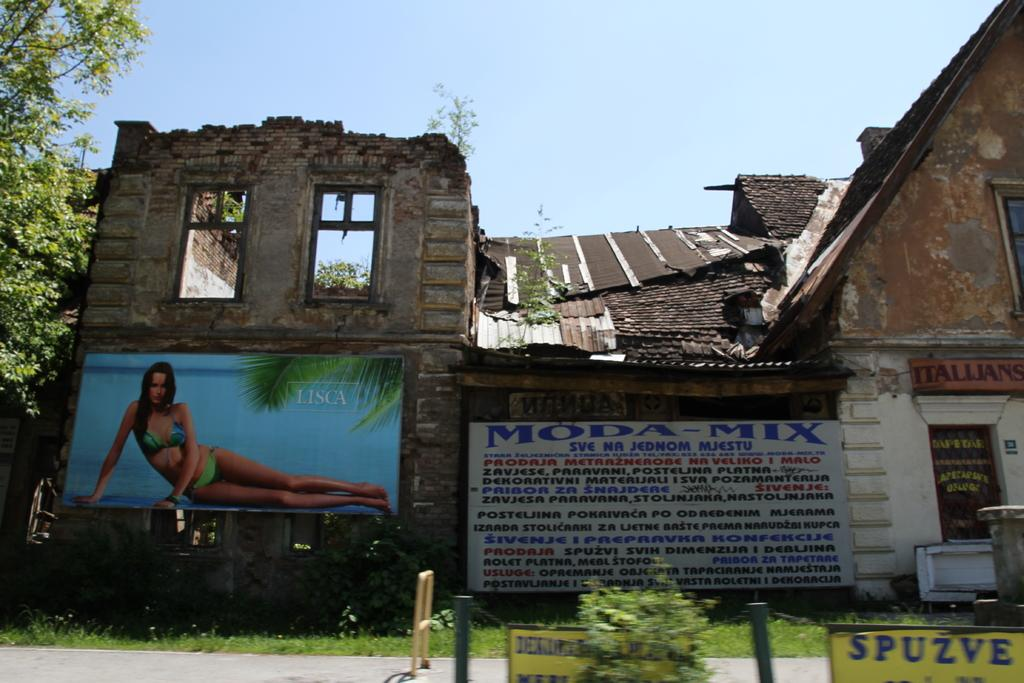What is the main subject in the center of the image? There is a building in the center of the image. What can be seen on the building? There are advertisements on the building. What is located at the bottom of the image? There is a road at the bottom of the image. What is present on the road? There are boards on the road. What can be seen in the background of the image? There is a tree and the sky visible in the background of the image. What type of oranges are being sold on the tree in the image? There are no oranges present in the image; it features a building with advertisements, a road with boards, and a tree in the background. How many wires are connected to the building in the image? There is no mention of wires connected to the building in the image; it only shows a building with advertisements, a road with boards, and a tree in the background. 